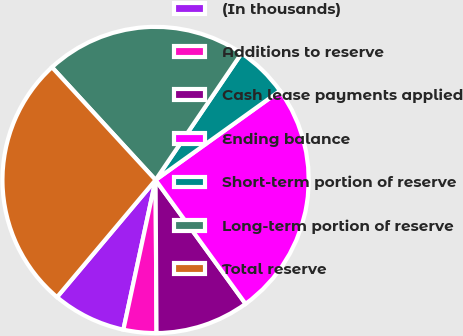Convert chart to OTSL. <chart><loc_0><loc_0><loc_500><loc_500><pie_chart><fcel>(In thousands)<fcel>Additions to reserve<fcel>Cash lease payments applied<fcel>Ending balance<fcel>Short-term portion of reserve<fcel>Long-term portion of reserve<fcel>Total reserve<nl><fcel>7.76%<fcel>3.47%<fcel>9.9%<fcel>24.9%<fcel>5.61%<fcel>21.32%<fcel>27.04%<nl></chart> 